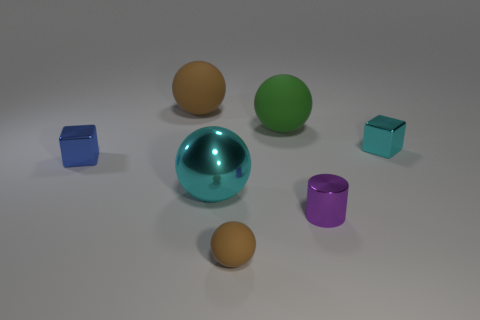Add 2 blocks. How many objects exist? 9 Subtract all spheres. How many objects are left? 3 Subtract all cyan metallic cylinders. Subtract all metal blocks. How many objects are left? 5 Add 5 big brown spheres. How many big brown spheres are left? 6 Add 3 purple rubber cylinders. How many purple rubber cylinders exist? 3 Subtract 0 red balls. How many objects are left? 7 